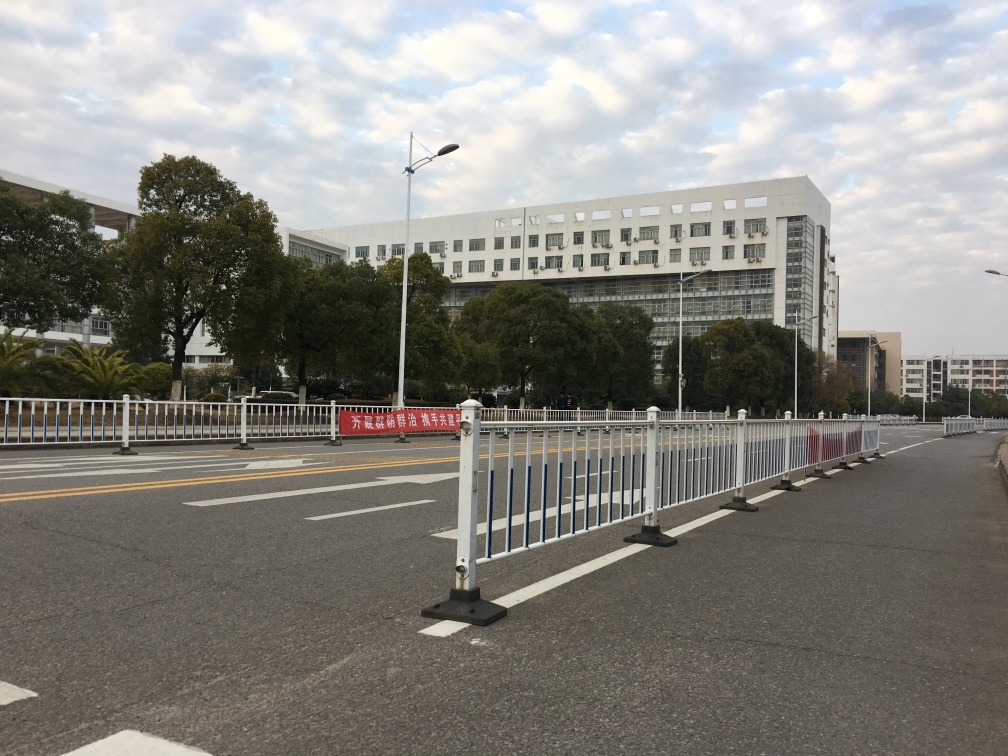What time of day does it appear to be in this image? It appears to be daytime, likely in the early morning or late afternoon, given the softness of the light and the long shadows being cast by objects in the image. 